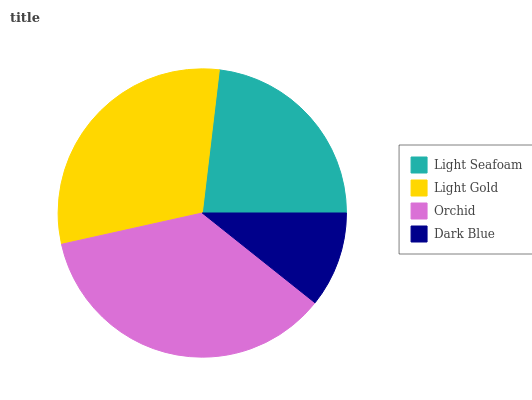Is Dark Blue the minimum?
Answer yes or no. Yes. Is Orchid the maximum?
Answer yes or no. Yes. Is Light Gold the minimum?
Answer yes or no. No. Is Light Gold the maximum?
Answer yes or no. No. Is Light Gold greater than Light Seafoam?
Answer yes or no. Yes. Is Light Seafoam less than Light Gold?
Answer yes or no. Yes. Is Light Seafoam greater than Light Gold?
Answer yes or no. No. Is Light Gold less than Light Seafoam?
Answer yes or no. No. Is Light Gold the high median?
Answer yes or no. Yes. Is Light Seafoam the low median?
Answer yes or no. Yes. Is Orchid the high median?
Answer yes or no. No. Is Dark Blue the low median?
Answer yes or no. No. 